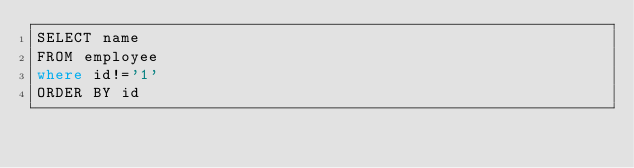<code> <loc_0><loc_0><loc_500><loc_500><_SQL_>SELECT name
FROM employee
where id!='1'
ORDER BY id

</code> 